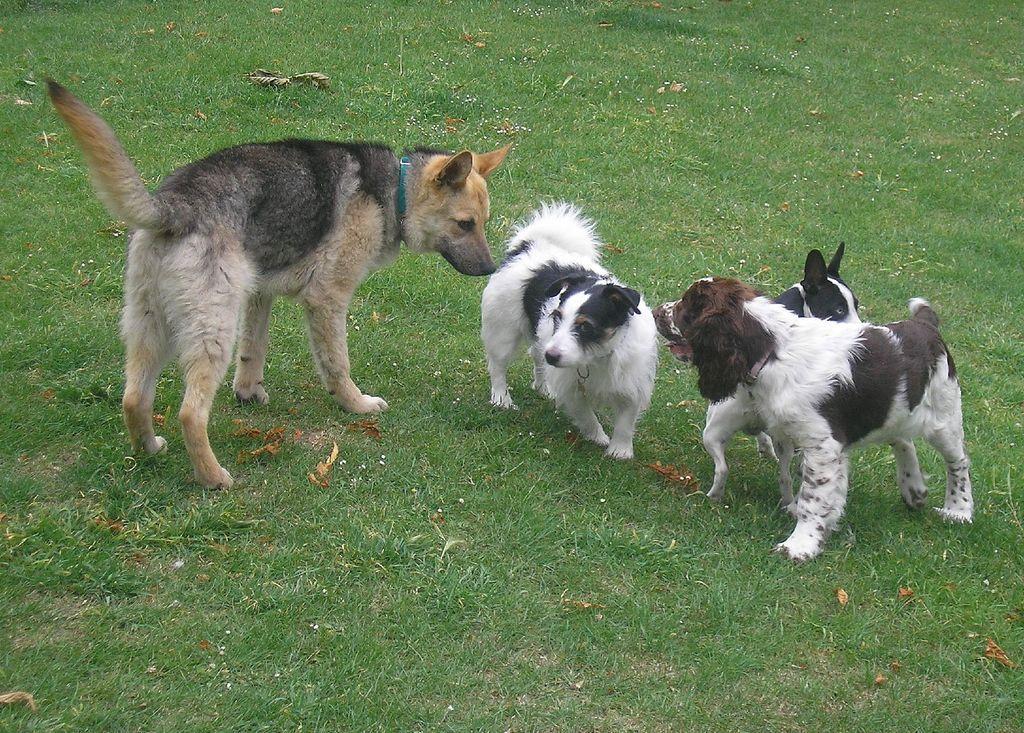Could you give a brief overview of what you see in this image? In this image we can see few dogs on the ground and also we can see the grass. 